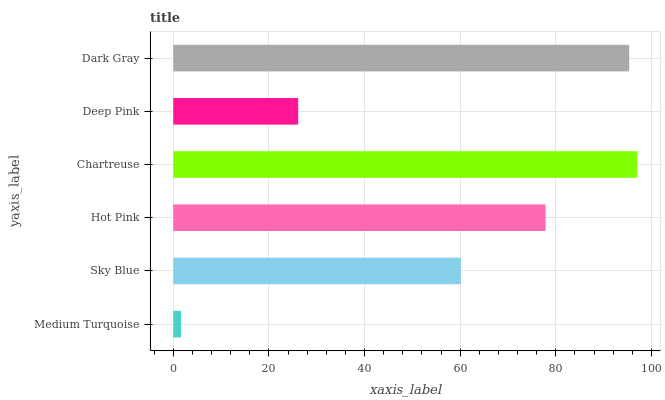Is Medium Turquoise the minimum?
Answer yes or no. Yes. Is Chartreuse the maximum?
Answer yes or no. Yes. Is Sky Blue the minimum?
Answer yes or no. No. Is Sky Blue the maximum?
Answer yes or no. No. Is Sky Blue greater than Medium Turquoise?
Answer yes or no. Yes. Is Medium Turquoise less than Sky Blue?
Answer yes or no. Yes. Is Medium Turquoise greater than Sky Blue?
Answer yes or no. No. Is Sky Blue less than Medium Turquoise?
Answer yes or no. No. Is Hot Pink the high median?
Answer yes or no. Yes. Is Sky Blue the low median?
Answer yes or no. Yes. Is Chartreuse the high median?
Answer yes or no. No. Is Deep Pink the low median?
Answer yes or no. No. 